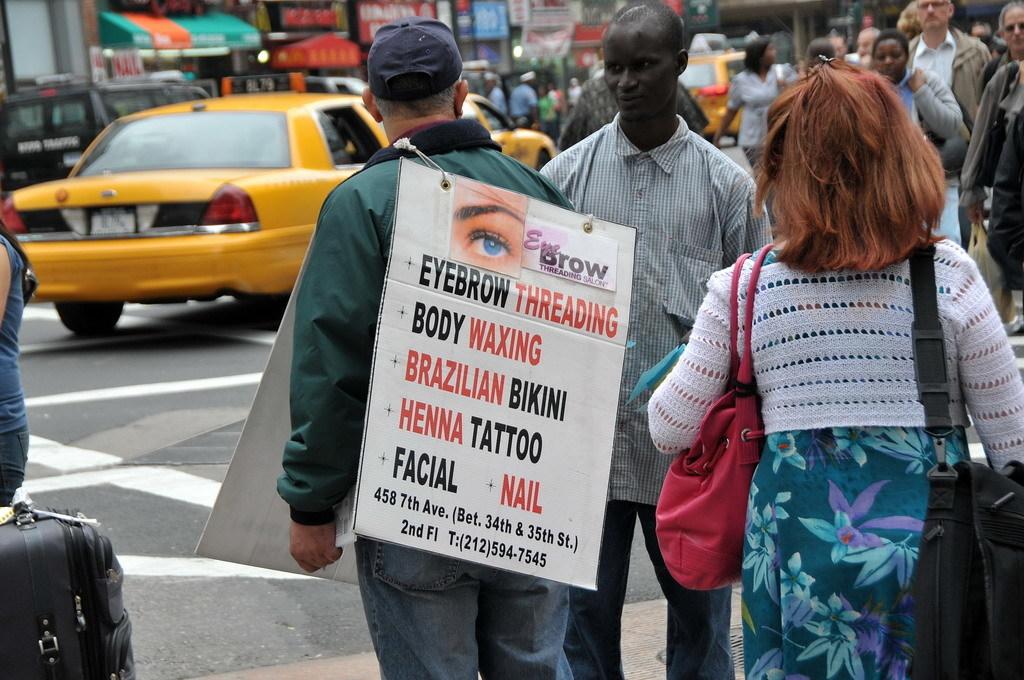What is written on his sign?
Provide a short and direct response. Eyebrow threading. 